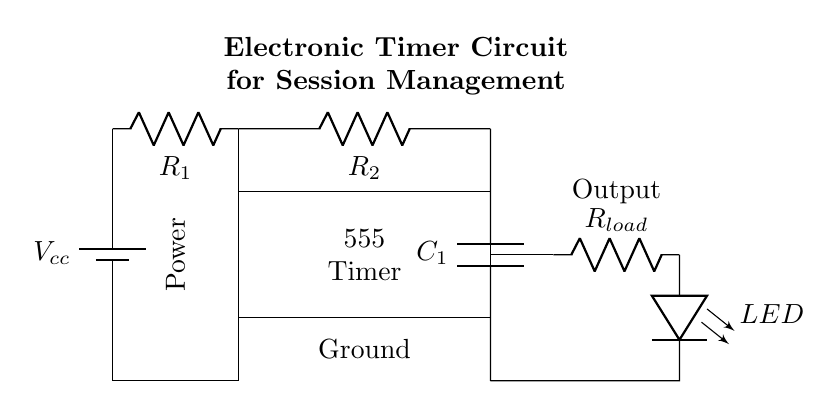What is the main component used for timing in this circuit? The 555 Timer IC is the main component responsible for timing in this circuit, as it is specifically designed for timing applications.
Answer: 555 Timer IC What does the LED indicate in this circuit? The LED functions as an indicator to show whether the output is active. When the output from the 555 Timer drives the LED, it lights up, indicating a timed session is occurring.
Answer: Indicator of active output What type of circuit is this? This is a timer circuit used for session management, indicating its function to regulate time-based activities.
Answer: Timer circuit What are the values of the resistors in this configuration? The resistors are labeled as R1 and R2, but the exact values are not specified in the diagram; specific values should be provided by the user during implementation.
Answer: Not specified How many capacitors does the circuit have? The circuit contains one capacitor, which is essential for the timing functionality of the 555 Timer.
Answer: One capacitor What is the purpose of the battery in this circuit? The battery provides the necessary voltage power supply for the entire circuit to operate, specifically powering the 555 Timer and other components.
Answer: Power supply How is the output connected in this circuit? The output is connected to a load resistor, which can further drive devices such as an LED to indicate the timing function in action.
Answer: To a load resistor 